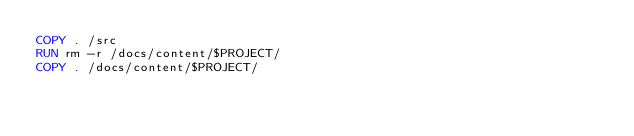<code> <loc_0><loc_0><loc_500><loc_500><_Dockerfile_>COPY . /src
RUN rm -r /docs/content/$PROJECT/
COPY . /docs/content/$PROJECT/
</code> 